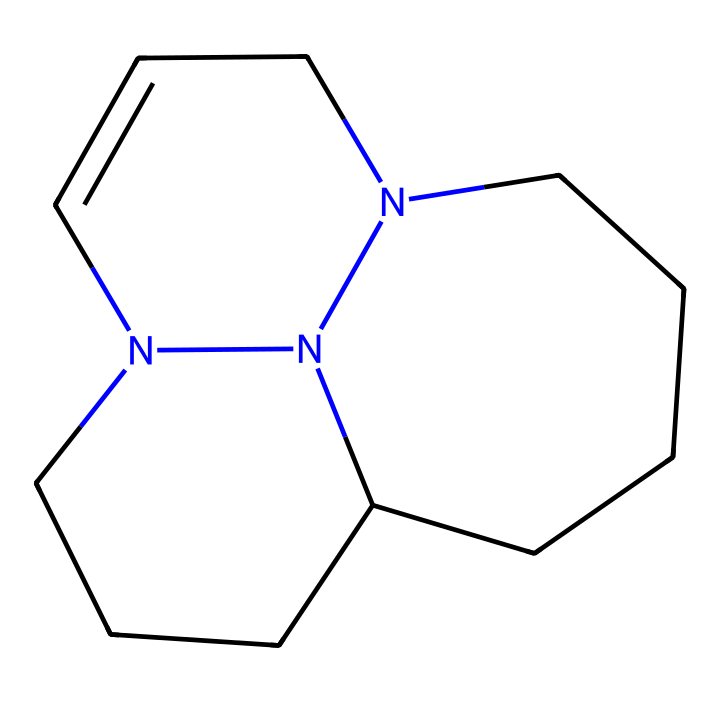What is the molecular formula of DBU? To find the molecular formula, we count all the atoms in the SMILES representation: C (carbon), N (nitrogen). The structure has 11 carbons and 2 nitrogens. Thus, the molecular formula is C11H18N2.
Answer: C11H18N2 How many rings are present in the structure of DBU? By analyzing the cyclic parts of the chemical structure represented in the SMILES, we observe there are two cycles present, forming a bicyclic compound.
Answer: 2 What type of base is DBU classified as? DBU is classified as a superbasic due to its high basicity compared to typical organic bases, which is attributed to its structural features, including the two nitrogen atoms that can stabilize positive charge.
Answer: superbasic What is the role of the nitrogen atoms in DBU? The nitrogen atoms in DBU function as electron pair donors, making it a strong base able to deprotonate compounds effectively. Their lone pairs are crucial in this property.
Answer: electron pair donors How does the bicyclic structure of DBU affect its basicity? The bicyclic structure facilitates the delocalization of charge and provides steric hindrance that stabilizes the positive charge on the nitrogen when it acts as a base. This stability enhances its basicity compared to acyclic analogs.
Answer: enhances basicity 